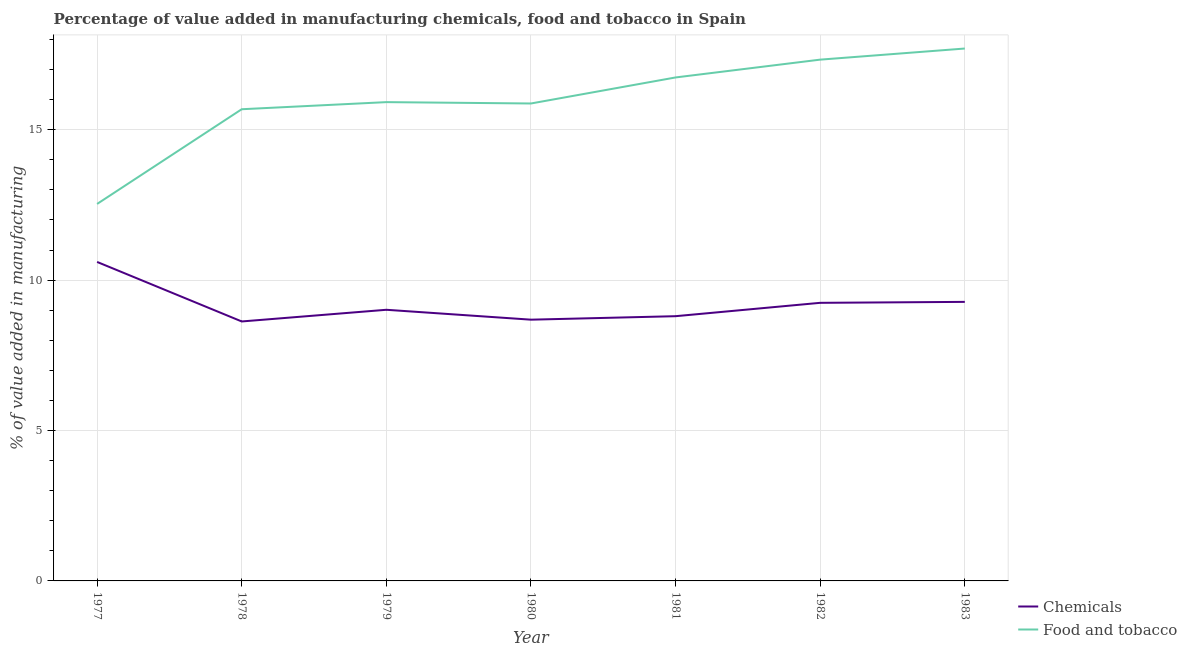How many different coloured lines are there?
Offer a very short reply. 2. What is the value added by manufacturing food and tobacco in 1977?
Ensure brevity in your answer.  12.53. Across all years, what is the maximum value added by  manufacturing chemicals?
Offer a terse response. 10.61. Across all years, what is the minimum value added by manufacturing food and tobacco?
Offer a very short reply. 12.53. What is the total value added by manufacturing food and tobacco in the graph?
Offer a terse response. 111.78. What is the difference between the value added by  manufacturing chemicals in 1979 and that in 1981?
Provide a short and direct response. 0.21. What is the difference between the value added by  manufacturing chemicals in 1978 and the value added by manufacturing food and tobacco in 1977?
Keep it short and to the point. -3.91. What is the average value added by manufacturing food and tobacco per year?
Your response must be concise. 15.97. In the year 1982, what is the difference between the value added by manufacturing food and tobacco and value added by  manufacturing chemicals?
Provide a short and direct response. 8.09. What is the ratio of the value added by manufacturing food and tobacco in 1980 to that in 1981?
Offer a terse response. 0.95. Is the difference between the value added by  manufacturing chemicals in 1982 and 1983 greater than the difference between the value added by manufacturing food and tobacco in 1982 and 1983?
Your answer should be compact. Yes. What is the difference between the highest and the second highest value added by manufacturing food and tobacco?
Give a very brief answer. 0.37. What is the difference between the highest and the lowest value added by  manufacturing chemicals?
Provide a succinct answer. 1.98. In how many years, is the value added by  manufacturing chemicals greater than the average value added by  manufacturing chemicals taken over all years?
Give a very brief answer. 3. Is the sum of the value added by  manufacturing chemicals in 1978 and 1982 greater than the maximum value added by manufacturing food and tobacco across all years?
Your answer should be compact. Yes. Is the value added by  manufacturing chemicals strictly greater than the value added by manufacturing food and tobacco over the years?
Your answer should be very brief. No. How many lines are there?
Offer a terse response. 2. Are the values on the major ticks of Y-axis written in scientific E-notation?
Your answer should be compact. No. Does the graph contain any zero values?
Give a very brief answer. No. How many legend labels are there?
Keep it short and to the point. 2. What is the title of the graph?
Provide a short and direct response. Percentage of value added in manufacturing chemicals, food and tobacco in Spain. Does "Register a business" appear as one of the legend labels in the graph?
Provide a succinct answer. No. What is the label or title of the X-axis?
Your answer should be very brief. Year. What is the label or title of the Y-axis?
Provide a succinct answer. % of value added in manufacturing. What is the % of value added in manufacturing of Chemicals in 1977?
Keep it short and to the point. 10.61. What is the % of value added in manufacturing of Food and tobacco in 1977?
Your response must be concise. 12.53. What is the % of value added in manufacturing of Chemicals in 1978?
Provide a succinct answer. 8.63. What is the % of value added in manufacturing in Food and tobacco in 1978?
Ensure brevity in your answer.  15.68. What is the % of value added in manufacturing in Chemicals in 1979?
Offer a very short reply. 9.01. What is the % of value added in manufacturing in Food and tobacco in 1979?
Offer a terse response. 15.92. What is the % of value added in manufacturing in Chemicals in 1980?
Your answer should be very brief. 8.69. What is the % of value added in manufacturing of Food and tobacco in 1980?
Provide a succinct answer. 15.87. What is the % of value added in manufacturing in Chemicals in 1981?
Offer a very short reply. 8.8. What is the % of value added in manufacturing of Food and tobacco in 1981?
Your answer should be very brief. 16.74. What is the % of value added in manufacturing of Chemicals in 1982?
Offer a terse response. 9.25. What is the % of value added in manufacturing in Food and tobacco in 1982?
Offer a terse response. 17.33. What is the % of value added in manufacturing in Chemicals in 1983?
Make the answer very short. 9.28. What is the % of value added in manufacturing in Food and tobacco in 1983?
Your answer should be very brief. 17.7. Across all years, what is the maximum % of value added in manufacturing in Chemicals?
Provide a short and direct response. 10.61. Across all years, what is the maximum % of value added in manufacturing in Food and tobacco?
Offer a very short reply. 17.7. Across all years, what is the minimum % of value added in manufacturing of Chemicals?
Keep it short and to the point. 8.63. Across all years, what is the minimum % of value added in manufacturing in Food and tobacco?
Offer a terse response. 12.53. What is the total % of value added in manufacturing of Chemicals in the graph?
Provide a succinct answer. 64.26. What is the total % of value added in manufacturing of Food and tobacco in the graph?
Ensure brevity in your answer.  111.78. What is the difference between the % of value added in manufacturing of Chemicals in 1977 and that in 1978?
Your answer should be very brief. 1.98. What is the difference between the % of value added in manufacturing in Food and tobacco in 1977 and that in 1978?
Your answer should be compact. -3.15. What is the difference between the % of value added in manufacturing in Chemicals in 1977 and that in 1979?
Give a very brief answer. 1.59. What is the difference between the % of value added in manufacturing in Food and tobacco in 1977 and that in 1979?
Make the answer very short. -3.39. What is the difference between the % of value added in manufacturing in Chemicals in 1977 and that in 1980?
Your response must be concise. 1.92. What is the difference between the % of value added in manufacturing of Food and tobacco in 1977 and that in 1980?
Your answer should be very brief. -3.34. What is the difference between the % of value added in manufacturing of Chemicals in 1977 and that in 1981?
Offer a very short reply. 1.8. What is the difference between the % of value added in manufacturing of Food and tobacco in 1977 and that in 1981?
Your answer should be very brief. -4.21. What is the difference between the % of value added in manufacturing in Chemicals in 1977 and that in 1982?
Ensure brevity in your answer.  1.36. What is the difference between the % of value added in manufacturing in Food and tobacco in 1977 and that in 1982?
Your answer should be compact. -4.8. What is the difference between the % of value added in manufacturing in Chemicals in 1977 and that in 1983?
Ensure brevity in your answer.  1.33. What is the difference between the % of value added in manufacturing of Food and tobacco in 1977 and that in 1983?
Make the answer very short. -5.17. What is the difference between the % of value added in manufacturing of Chemicals in 1978 and that in 1979?
Offer a terse response. -0.39. What is the difference between the % of value added in manufacturing of Food and tobacco in 1978 and that in 1979?
Keep it short and to the point. -0.24. What is the difference between the % of value added in manufacturing in Chemicals in 1978 and that in 1980?
Provide a succinct answer. -0.06. What is the difference between the % of value added in manufacturing of Food and tobacco in 1978 and that in 1980?
Give a very brief answer. -0.19. What is the difference between the % of value added in manufacturing in Chemicals in 1978 and that in 1981?
Your answer should be compact. -0.18. What is the difference between the % of value added in manufacturing of Food and tobacco in 1978 and that in 1981?
Your answer should be very brief. -1.06. What is the difference between the % of value added in manufacturing in Chemicals in 1978 and that in 1982?
Your answer should be compact. -0.62. What is the difference between the % of value added in manufacturing in Food and tobacco in 1978 and that in 1982?
Your answer should be very brief. -1.65. What is the difference between the % of value added in manufacturing in Chemicals in 1978 and that in 1983?
Your answer should be compact. -0.65. What is the difference between the % of value added in manufacturing of Food and tobacco in 1978 and that in 1983?
Provide a succinct answer. -2.02. What is the difference between the % of value added in manufacturing in Chemicals in 1979 and that in 1980?
Make the answer very short. 0.33. What is the difference between the % of value added in manufacturing of Food and tobacco in 1979 and that in 1980?
Provide a short and direct response. 0.05. What is the difference between the % of value added in manufacturing in Chemicals in 1979 and that in 1981?
Offer a terse response. 0.21. What is the difference between the % of value added in manufacturing of Food and tobacco in 1979 and that in 1981?
Your answer should be compact. -0.82. What is the difference between the % of value added in manufacturing of Chemicals in 1979 and that in 1982?
Give a very brief answer. -0.23. What is the difference between the % of value added in manufacturing in Food and tobacco in 1979 and that in 1982?
Keep it short and to the point. -1.41. What is the difference between the % of value added in manufacturing in Chemicals in 1979 and that in 1983?
Keep it short and to the point. -0.26. What is the difference between the % of value added in manufacturing of Food and tobacco in 1979 and that in 1983?
Ensure brevity in your answer.  -1.78. What is the difference between the % of value added in manufacturing of Chemicals in 1980 and that in 1981?
Your response must be concise. -0.12. What is the difference between the % of value added in manufacturing of Food and tobacco in 1980 and that in 1981?
Offer a terse response. -0.87. What is the difference between the % of value added in manufacturing in Chemicals in 1980 and that in 1982?
Give a very brief answer. -0.56. What is the difference between the % of value added in manufacturing of Food and tobacco in 1980 and that in 1982?
Provide a short and direct response. -1.46. What is the difference between the % of value added in manufacturing in Chemicals in 1980 and that in 1983?
Ensure brevity in your answer.  -0.59. What is the difference between the % of value added in manufacturing in Food and tobacco in 1980 and that in 1983?
Provide a succinct answer. -1.83. What is the difference between the % of value added in manufacturing in Chemicals in 1981 and that in 1982?
Keep it short and to the point. -0.44. What is the difference between the % of value added in manufacturing in Food and tobacco in 1981 and that in 1982?
Your answer should be compact. -0.59. What is the difference between the % of value added in manufacturing in Chemicals in 1981 and that in 1983?
Provide a succinct answer. -0.48. What is the difference between the % of value added in manufacturing in Food and tobacco in 1981 and that in 1983?
Offer a very short reply. -0.96. What is the difference between the % of value added in manufacturing of Chemicals in 1982 and that in 1983?
Your answer should be compact. -0.03. What is the difference between the % of value added in manufacturing of Food and tobacco in 1982 and that in 1983?
Provide a succinct answer. -0.37. What is the difference between the % of value added in manufacturing in Chemicals in 1977 and the % of value added in manufacturing in Food and tobacco in 1978?
Give a very brief answer. -5.08. What is the difference between the % of value added in manufacturing in Chemicals in 1977 and the % of value added in manufacturing in Food and tobacco in 1979?
Provide a succinct answer. -5.31. What is the difference between the % of value added in manufacturing in Chemicals in 1977 and the % of value added in manufacturing in Food and tobacco in 1980?
Your answer should be very brief. -5.27. What is the difference between the % of value added in manufacturing of Chemicals in 1977 and the % of value added in manufacturing of Food and tobacco in 1981?
Provide a short and direct response. -6.13. What is the difference between the % of value added in manufacturing of Chemicals in 1977 and the % of value added in manufacturing of Food and tobacco in 1982?
Provide a short and direct response. -6.73. What is the difference between the % of value added in manufacturing of Chemicals in 1977 and the % of value added in manufacturing of Food and tobacco in 1983?
Keep it short and to the point. -7.1. What is the difference between the % of value added in manufacturing of Chemicals in 1978 and the % of value added in manufacturing of Food and tobacco in 1979?
Provide a short and direct response. -7.29. What is the difference between the % of value added in manufacturing in Chemicals in 1978 and the % of value added in manufacturing in Food and tobacco in 1980?
Keep it short and to the point. -7.25. What is the difference between the % of value added in manufacturing in Chemicals in 1978 and the % of value added in manufacturing in Food and tobacco in 1981?
Offer a terse response. -8.11. What is the difference between the % of value added in manufacturing of Chemicals in 1978 and the % of value added in manufacturing of Food and tobacco in 1982?
Offer a terse response. -8.7. What is the difference between the % of value added in manufacturing in Chemicals in 1978 and the % of value added in manufacturing in Food and tobacco in 1983?
Offer a terse response. -9.07. What is the difference between the % of value added in manufacturing of Chemicals in 1979 and the % of value added in manufacturing of Food and tobacco in 1980?
Your answer should be compact. -6.86. What is the difference between the % of value added in manufacturing of Chemicals in 1979 and the % of value added in manufacturing of Food and tobacco in 1981?
Keep it short and to the point. -7.72. What is the difference between the % of value added in manufacturing of Chemicals in 1979 and the % of value added in manufacturing of Food and tobacco in 1982?
Your response must be concise. -8.32. What is the difference between the % of value added in manufacturing of Chemicals in 1979 and the % of value added in manufacturing of Food and tobacco in 1983?
Your answer should be compact. -8.69. What is the difference between the % of value added in manufacturing in Chemicals in 1980 and the % of value added in manufacturing in Food and tobacco in 1981?
Provide a succinct answer. -8.05. What is the difference between the % of value added in manufacturing in Chemicals in 1980 and the % of value added in manufacturing in Food and tobacco in 1982?
Provide a short and direct response. -8.65. What is the difference between the % of value added in manufacturing of Chemicals in 1980 and the % of value added in manufacturing of Food and tobacco in 1983?
Provide a succinct answer. -9.02. What is the difference between the % of value added in manufacturing in Chemicals in 1981 and the % of value added in manufacturing in Food and tobacco in 1982?
Ensure brevity in your answer.  -8.53. What is the difference between the % of value added in manufacturing of Chemicals in 1981 and the % of value added in manufacturing of Food and tobacco in 1983?
Your response must be concise. -8.9. What is the difference between the % of value added in manufacturing of Chemicals in 1982 and the % of value added in manufacturing of Food and tobacco in 1983?
Give a very brief answer. -8.45. What is the average % of value added in manufacturing in Chemicals per year?
Provide a short and direct response. 9.18. What is the average % of value added in manufacturing in Food and tobacco per year?
Your response must be concise. 15.97. In the year 1977, what is the difference between the % of value added in manufacturing in Chemicals and % of value added in manufacturing in Food and tobacco?
Make the answer very short. -1.93. In the year 1978, what is the difference between the % of value added in manufacturing of Chemicals and % of value added in manufacturing of Food and tobacco?
Your response must be concise. -7.06. In the year 1979, what is the difference between the % of value added in manufacturing in Chemicals and % of value added in manufacturing in Food and tobacco?
Provide a succinct answer. -6.9. In the year 1980, what is the difference between the % of value added in manufacturing in Chemicals and % of value added in manufacturing in Food and tobacco?
Offer a very short reply. -7.19. In the year 1981, what is the difference between the % of value added in manufacturing of Chemicals and % of value added in manufacturing of Food and tobacco?
Your answer should be compact. -7.94. In the year 1982, what is the difference between the % of value added in manufacturing of Chemicals and % of value added in manufacturing of Food and tobacco?
Your response must be concise. -8.09. In the year 1983, what is the difference between the % of value added in manufacturing of Chemicals and % of value added in manufacturing of Food and tobacco?
Your response must be concise. -8.42. What is the ratio of the % of value added in manufacturing in Chemicals in 1977 to that in 1978?
Keep it short and to the point. 1.23. What is the ratio of the % of value added in manufacturing in Food and tobacco in 1977 to that in 1978?
Offer a terse response. 0.8. What is the ratio of the % of value added in manufacturing of Chemicals in 1977 to that in 1979?
Ensure brevity in your answer.  1.18. What is the ratio of the % of value added in manufacturing of Food and tobacco in 1977 to that in 1979?
Ensure brevity in your answer.  0.79. What is the ratio of the % of value added in manufacturing in Chemicals in 1977 to that in 1980?
Offer a terse response. 1.22. What is the ratio of the % of value added in manufacturing of Food and tobacco in 1977 to that in 1980?
Provide a short and direct response. 0.79. What is the ratio of the % of value added in manufacturing in Chemicals in 1977 to that in 1981?
Offer a very short reply. 1.2. What is the ratio of the % of value added in manufacturing of Food and tobacco in 1977 to that in 1981?
Give a very brief answer. 0.75. What is the ratio of the % of value added in manufacturing in Chemicals in 1977 to that in 1982?
Your answer should be very brief. 1.15. What is the ratio of the % of value added in manufacturing of Food and tobacco in 1977 to that in 1982?
Keep it short and to the point. 0.72. What is the ratio of the % of value added in manufacturing of Chemicals in 1977 to that in 1983?
Keep it short and to the point. 1.14. What is the ratio of the % of value added in manufacturing in Food and tobacco in 1977 to that in 1983?
Offer a terse response. 0.71. What is the ratio of the % of value added in manufacturing in Chemicals in 1978 to that in 1979?
Your answer should be very brief. 0.96. What is the ratio of the % of value added in manufacturing in Food and tobacco in 1978 to that in 1979?
Ensure brevity in your answer.  0.99. What is the ratio of the % of value added in manufacturing in Chemicals in 1978 to that in 1980?
Keep it short and to the point. 0.99. What is the ratio of the % of value added in manufacturing in Food and tobacco in 1978 to that in 1980?
Offer a very short reply. 0.99. What is the ratio of the % of value added in manufacturing of Chemicals in 1978 to that in 1981?
Your response must be concise. 0.98. What is the ratio of the % of value added in manufacturing in Food and tobacco in 1978 to that in 1981?
Give a very brief answer. 0.94. What is the ratio of the % of value added in manufacturing in Chemicals in 1978 to that in 1982?
Your answer should be compact. 0.93. What is the ratio of the % of value added in manufacturing in Food and tobacco in 1978 to that in 1982?
Your answer should be compact. 0.9. What is the ratio of the % of value added in manufacturing of Chemicals in 1978 to that in 1983?
Your response must be concise. 0.93. What is the ratio of the % of value added in manufacturing in Food and tobacco in 1978 to that in 1983?
Provide a short and direct response. 0.89. What is the ratio of the % of value added in manufacturing of Chemicals in 1979 to that in 1980?
Provide a succinct answer. 1.04. What is the ratio of the % of value added in manufacturing of Food and tobacco in 1979 to that in 1980?
Give a very brief answer. 1. What is the ratio of the % of value added in manufacturing of Chemicals in 1979 to that in 1981?
Your answer should be very brief. 1.02. What is the ratio of the % of value added in manufacturing in Food and tobacco in 1979 to that in 1981?
Give a very brief answer. 0.95. What is the ratio of the % of value added in manufacturing of Chemicals in 1979 to that in 1982?
Make the answer very short. 0.97. What is the ratio of the % of value added in manufacturing in Food and tobacco in 1979 to that in 1982?
Provide a succinct answer. 0.92. What is the ratio of the % of value added in manufacturing of Chemicals in 1979 to that in 1983?
Provide a succinct answer. 0.97. What is the ratio of the % of value added in manufacturing of Food and tobacco in 1979 to that in 1983?
Keep it short and to the point. 0.9. What is the ratio of the % of value added in manufacturing of Chemicals in 1980 to that in 1981?
Provide a succinct answer. 0.99. What is the ratio of the % of value added in manufacturing of Food and tobacco in 1980 to that in 1981?
Ensure brevity in your answer.  0.95. What is the ratio of the % of value added in manufacturing of Chemicals in 1980 to that in 1982?
Provide a succinct answer. 0.94. What is the ratio of the % of value added in manufacturing in Food and tobacco in 1980 to that in 1982?
Your answer should be very brief. 0.92. What is the ratio of the % of value added in manufacturing of Chemicals in 1980 to that in 1983?
Your answer should be very brief. 0.94. What is the ratio of the % of value added in manufacturing of Food and tobacco in 1980 to that in 1983?
Make the answer very short. 0.9. What is the ratio of the % of value added in manufacturing in Chemicals in 1981 to that in 1982?
Ensure brevity in your answer.  0.95. What is the ratio of the % of value added in manufacturing in Food and tobacco in 1981 to that in 1982?
Your answer should be very brief. 0.97. What is the ratio of the % of value added in manufacturing of Chemicals in 1981 to that in 1983?
Ensure brevity in your answer.  0.95. What is the ratio of the % of value added in manufacturing in Food and tobacco in 1981 to that in 1983?
Offer a terse response. 0.95. What is the ratio of the % of value added in manufacturing of Chemicals in 1982 to that in 1983?
Your response must be concise. 1. What is the ratio of the % of value added in manufacturing in Food and tobacco in 1982 to that in 1983?
Keep it short and to the point. 0.98. What is the difference between the highest and the second highest % of value added in manufacturing in Chemicals?
Give a very brief answer. 1.33. What is the difference between the highest and the second highest % of value added in manufacturing of Food and tobacco?
Ensure brevity in your answer.  0.37. What is the difference between the highest and the lowest % of value added in manufacturing in Chemicals?
Make the answer very short. 1.98. What is the difference between the highest and the lowest % of value added in manufacturing of Food and tobacco?
Your response must be concise. 5.17. 